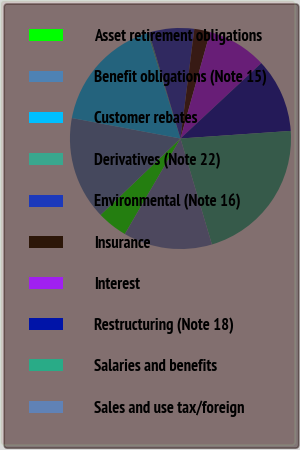Convert chart to OTSL. <chart><loc_0><loc_0><loc_500><loc_500><pie_chart><fcel>Asset retirement obligations<fcel>Benefit obligations (Note 15)<fcel>Customer rebates<fcel>Derivatives (Note 22)<fcel>Environmental (Note 16)<fcel>Insurance<fcel>Interest<fcel>Restructuring (Note 18)<fcel>Salaries and benefits<fcel>Sales and use tax/foreign<nl><fcel>4.46%<fcel>15.11%<fcel>17.24%<fcel>0.2%<fcel>6.59%<fcel>2.33%<fcel>8.72%<fcel>10.85%<fcel>21.5%<fcel>12.98%<nl></chart> 